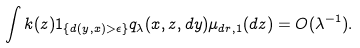<formula> <loc_0><loc_0><loc_500><loc_500>\int k ( z ) { 1 } _ { \{ d ( y , x ) > \epsilon \} } q _ { \lambda } ( x , z , d y ) \mu _ { d r , 1 } ( d z ) = O ( \lambda ^ { - 1 } ) .</formula> 